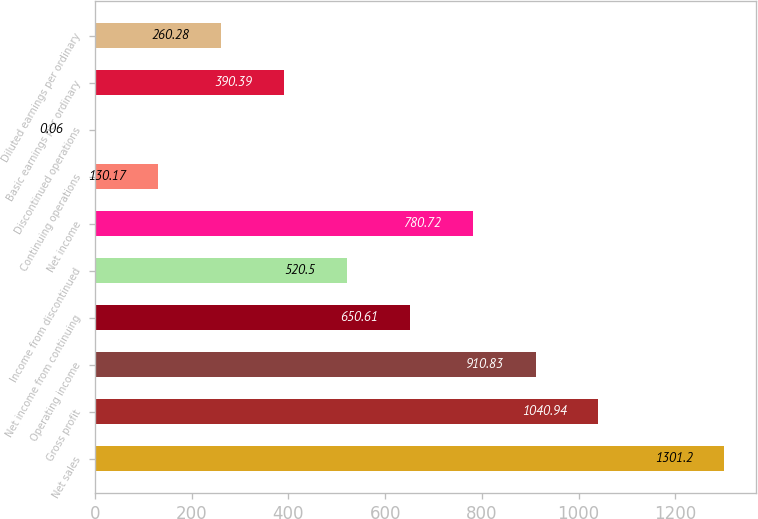Convert chart. <chart><loc_0><loc_0><loc_500><loc_500><bar_chart><fcel>Net sales<fcel>Gross profit<fcel>Operating income<fcel>Net income from continuing<fcel>Income from discontinued<fcel>Net income<fcel>Continuing operations<fcel>Discontinued operations<fcel>Basic earnings per ordinary<fcel>Diluted earnings per ordinary<nl><fcel>1301.2<fcel>1040.94<fcel>910.83<fcel>650.61<fcel>520.5<fcel>780.72<fcel>130.17<fcel>0.06<fcel>390.39<fcel>260.28<nl></chart> 